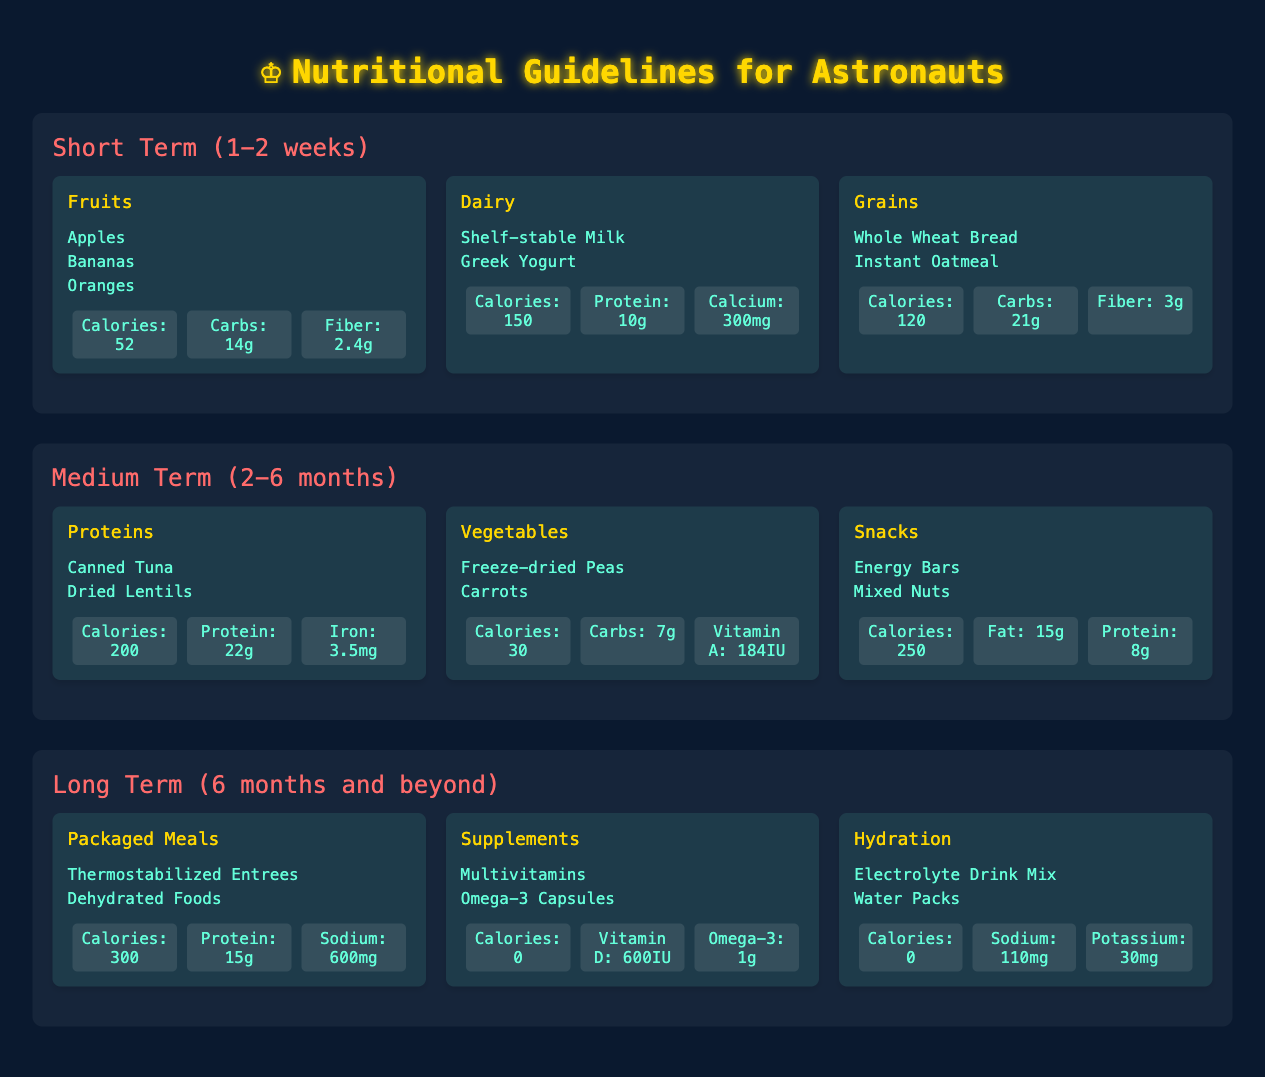What are the examples of fruits recommended for short-term space travel? The table clearly lists the examples of fruits under the short-term food category. They include Apples, Bananas, and Oranges.
Answer: Apples, Bananas, Oranges How many calories does dairy provide for short-term space travel? From the table, the nutritional values for Dairy under short-term food category show it provides 150 calories.
Answer: 150 Which food category has the highest calories for medium-term space travel? In the table, by checking the calorie values, Snacks provide 250 calories, which is higher than any other food category in medium-term, such as Proteins (200 calories) and Vegetables (30 calories).
Answer: Snacks Is it true that freeze-dried peas provide 30 calories? The table lists the nutritional values for Vegetables, where freeze-dried peas are included, and indicates that they provide 30 calories. Therefore, the statement is true.
Answer: True What is the total calorie count from fruits and grains during short-term space travel? To find the total calories from Fruits (52 calories) and Grains (120 calories), add them together: 52 + 120 = 172.
Answer: 172 How much protein do packaged meals provide during long-term space travel? The nutritional values for Packaged Meals in the table indicate that they provide 15 grams of protein.
Answer: 15 What is the average sodium content in hydration and packaged meals for long-term space travel? The sodium value for Hydration is 110 mg, and for Packaged Meals, it's 600 mg. To find the average, sum them: 110 + 600 = 710 mg, then divide by 2: 710/2 = 355 mg.
Answer: 355 Do supplements provide any calories according to the table? The table indicates that the caloric value for Supplements is listed as 0 calories. Therefore, the answer is no.
Answer: No What types of food are recommended for medium-term space travel that fall under the protein category? The table specifies that Proteins include Canned Tuna and Dried Lentils for medium-term space travel.
Answer: Canned Tuna, Dried Lentils 